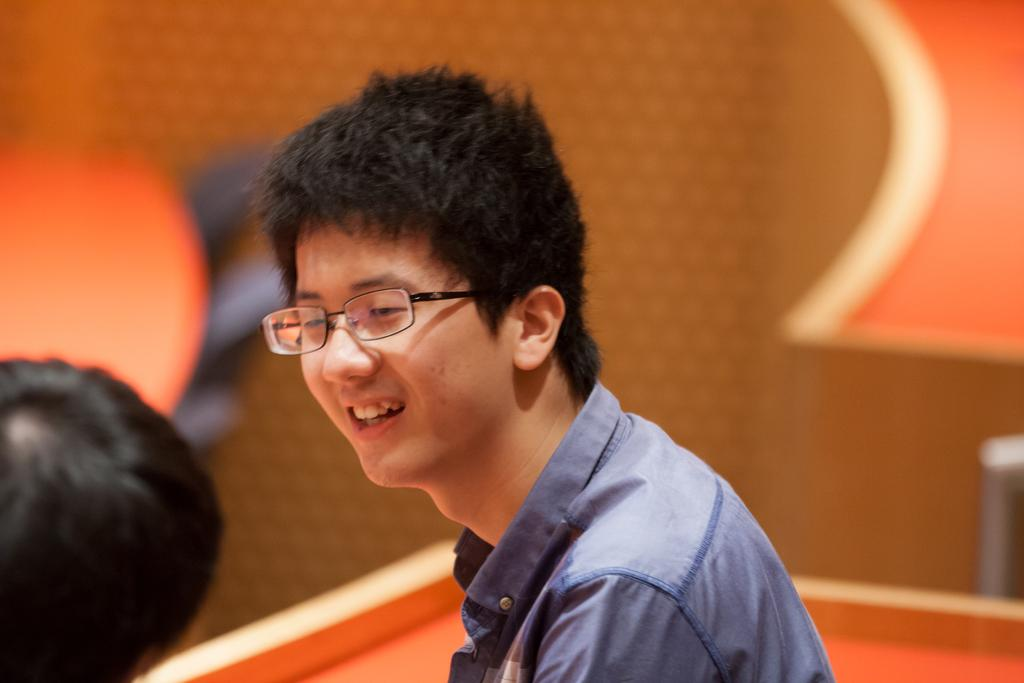Who can be seen in the image? There are people in the image. Can you describe one of the individuals in the image? There is a man in the image. What accessory is the man wearing in the image? The man is wearing spectacles. What type of skate is the man using in the image? There is no skate present in the image. Where is the camp located in the image? There is no camp present in the image. 